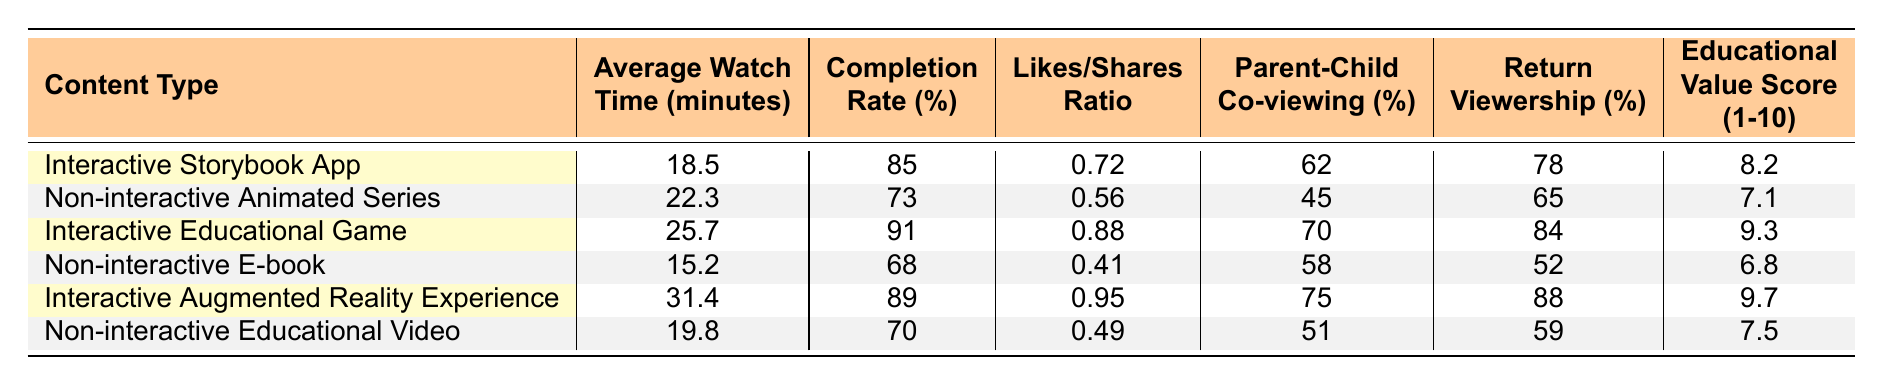What is the average watch time for the Interactive Storybook App? The table shows that the Average Watch Time for the Interactive Storybook App is 18.5 minutes.
Answer: 18.5 minutes What is the completion rate for Non-interactive Animated Series? The table indicates that the Completion Rate for Non-interactive Animated Series is 73%.
Answer: 73% Which content type has the highest Educational Value Score? The Educational Value Scores for each content type are: Interactive Storybook App (8.2), Non-interactive Animated Series (7.1), Interactive Educational Game (9.3), Non-interactive E-book (6.8), Interactive Augmented Reality Experience (9.7), Non-interactive Educational Video (7.5). The highest score is 9.7 for Interactive Augmented Reality Experience.
Answer: Interactive Augmented Reality Experience What is the difference in average watch time between the Interactive Educational Game and Non-interactive E-book? The Average Watch Time for Interactive Educational Game is 25.7 minutes and for Non-interactive E-book is 15.2 minutes. The difference is 25.7 - 15.2 = 10.5 minutes.
Answer: 10.5 minutes How many content types have a completion rate over 80%? The completion rates are: Interactive Storybook App (85%), Non-interactive Animated Series (73%), Interactive Educational Game (91%), Non-interactive E-book (68%), Interactive Augmented Reality Experience (89%), Non-interactive Educational Video (70%). There are 3 content types (Interactive Storybook App, Interactive Educational Game, and Interactive Augmented Reality Experience) with completion rates over 80%.
Answer: 3 Is the Likes/Shares ratio higher for Interactive content compared to Non-interactive content? The Likes/Shares ratios for Interactive content are: Interactive Storybook App (0.72), Interactive Educational Game (0.88), Interactive Augmented Reality Experience (0.95). For Non-interactive content, the ratios are: Non-interactive Animated Series (0.56), Non-interactive E-book (0.41), Non-interactive Educational Video (0.49). All interactive content ratios are higher than those of non-interactive content.
Answer: Yes What is the total percentage of return viewership for all Interactive content types? The return viewership percentages for Interactive content are: Interactive Storybook App (78%), Interactive Educational Game (84%), and Interactive Augmented Reality Experience (88%). Adding these together gives 78 + 84 + 88 = 250%. For total viewership, we then compute an average by dividing by 3 (the number of interactive types), which results in 250%/3 ≈ 83.33%.
Answer: 83.33% Which Interactive content type has the highest Parent-Child Co-viewing percentage? The Parent-Child Co-viewing percentages are: Interactive Storybook App (62%), Interactive Educational Game (70%), Interactive Augmented Reality Experience (75%). The highest is 75% for Interactive Augmented Reality Experience.
Answer: Interactive Augmented Reality Experience Is the Educational Value Score for Non-interactive E-book higher than that for Non-interactive Animated Series? The scores are: Non-interactive E-book (6.8) and Non-interactive Animated Series (7.1). Since 6.8 is less than 7.1, the score for Non-interactive E-book is not higher.
Answer: No What is the average Completion Rate across all content types? The completion rates are: 85, 73, 91, 68, 89, and 70. Adding these gives 85 + 73 + 91 + 68 + 89 + 70 = 476. There are 6 content types, so the average is 476/6 ≈ 79.33%.
Answer: 79.33% 